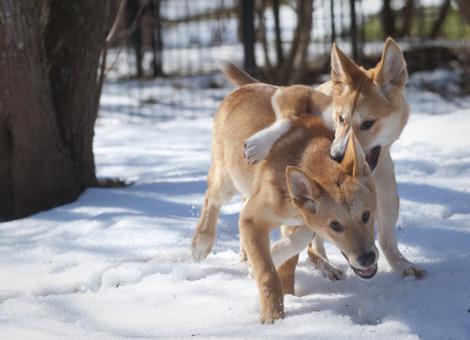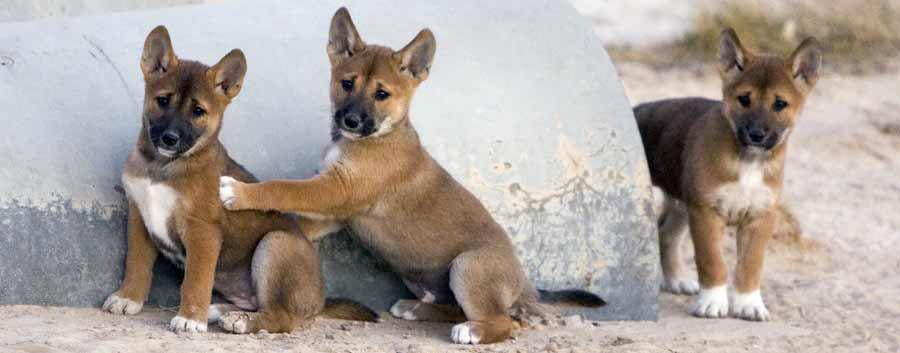The first image is the image on the left, the second image is the image on the right. Analyze the images presented: Is the assertion "There are multiple canine laying down with there feet in front of them." valid? Answer yes or no. No. 